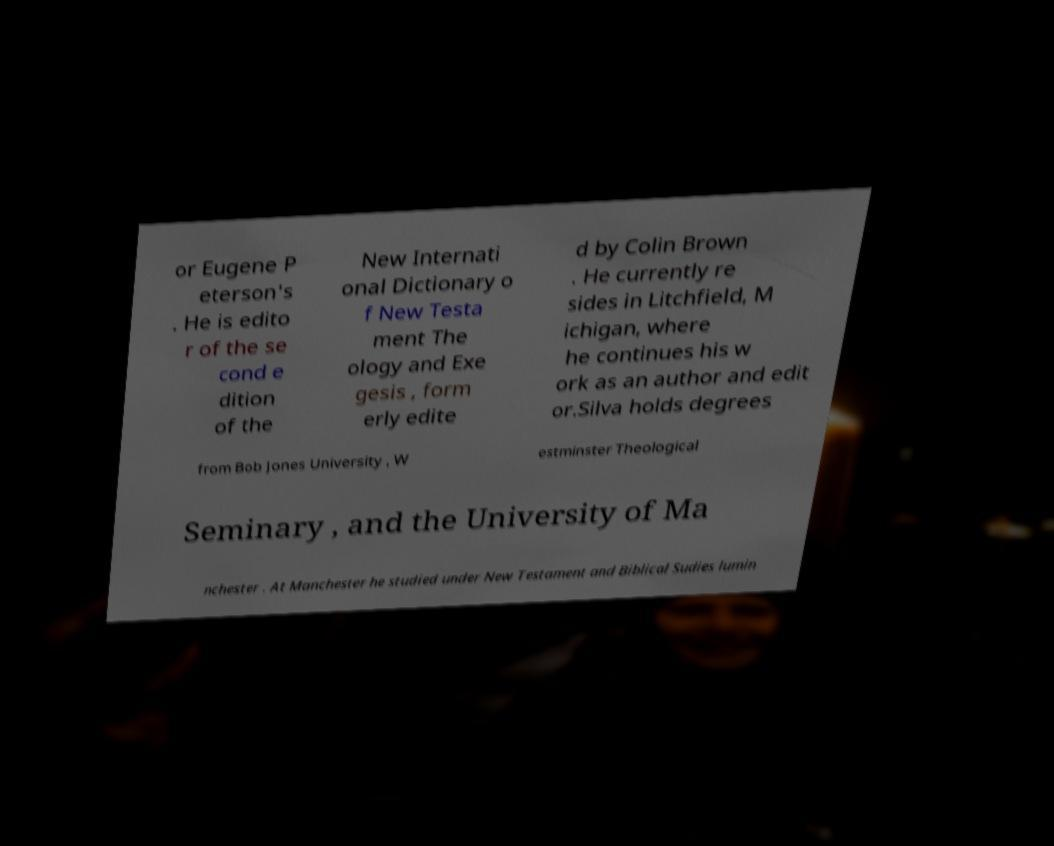I need the written content from this picture converted into text. Can you do that? or Eugene P eterson's . He is edito r of the se cond e dition of the New Internati onal Dictionary o f New Testa ment The ology and Exe gesis , form erly edite d by Colin Brown . He currently re sides in Litchfield, M ichigan, where he continues his w ork as an author and edit or.Silva holds degrees from Bob Jones University , W estminster Theological Seminary , and the University of Ma nchester . At Manchester he studied under New Testament and Biblical Sudies lumin 